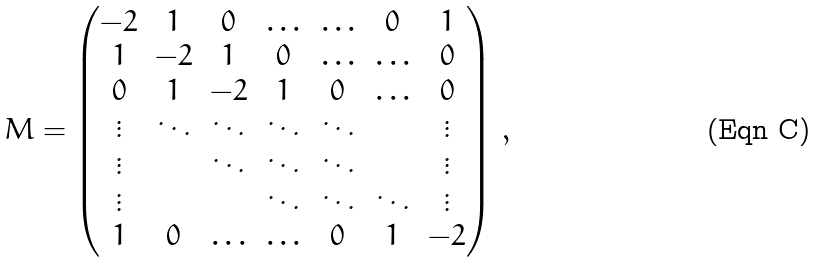<formula> <loc_0><loc_0><loc_500><loc_500>M = \left ( \begin{matrix} - 2 & 1 & 0 & \hdots & \hdots & 0 & 1 \\ 1 & - 2 & 1 & 0 & \hdots & \hdots & 0 \\ 0 & 1 & - 2 & 1 & 0 & \hdots & 0 \\ \vdots & \ddots & \ddots & \ddots & \ddots & & \vdots \\ \vdots & & \ddots & \ddots & \ddots & & \vdots \\ \vdots & & & \ddots & \ddots & \ddots & \vdots \\ 1 & 0 & \hdots & \hdots & 0 & 1 & - 2 \end{matrix} \right ) \, ,</formula> 